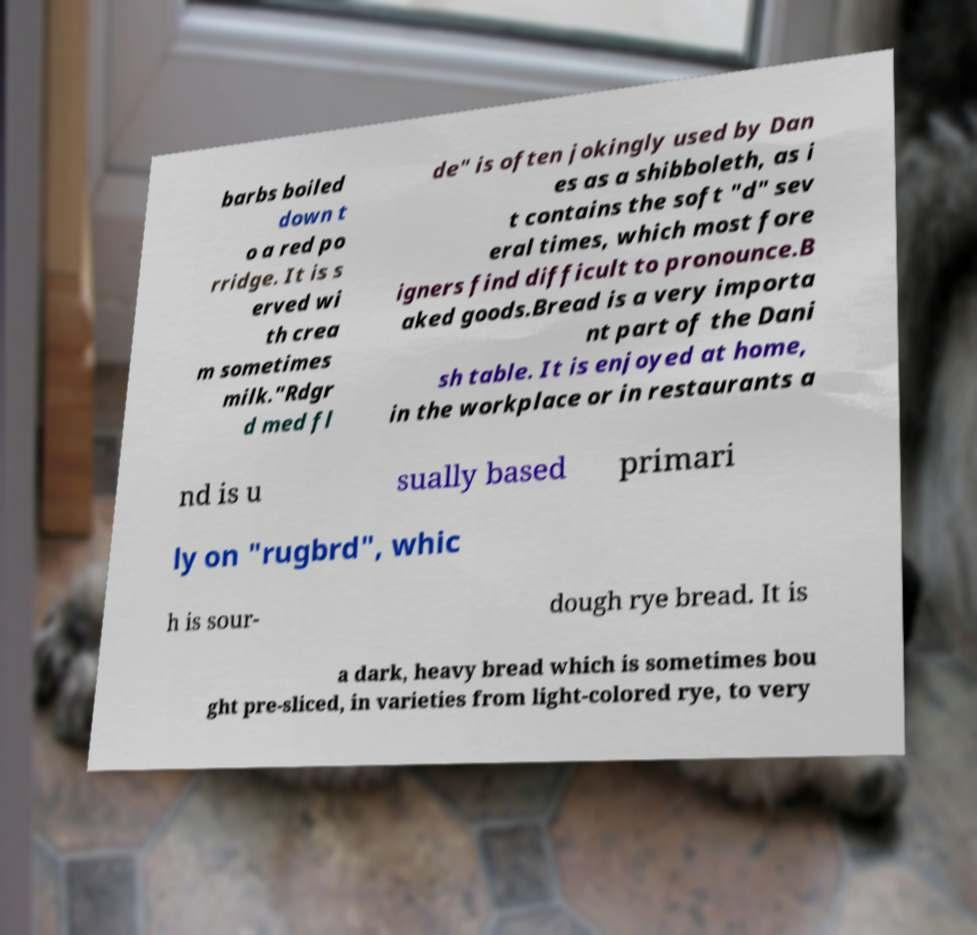Can you accurately transcribe the text from the provided image for me? barbs boiled down t o a red po rridge. It is s erved wi th crea m sometimes milk."Rdgr d med fl de" is often jokingly used by Dan es as a shibboleth, as i t contains the soft "d" sev eral times, which most fore igners find difficult to pronounce.B aked goods.Bread is a very importa nt part of the Dani sh table. It is enjoyed at home, in the workplace or in restaurants a nd is u sually based primari ly on "rugbrd", whic h is sour- dough rye bread. It is a dark, heavy bread which is sometimes bou ght pre-sliced, in varieties from light-colored rye, to very 